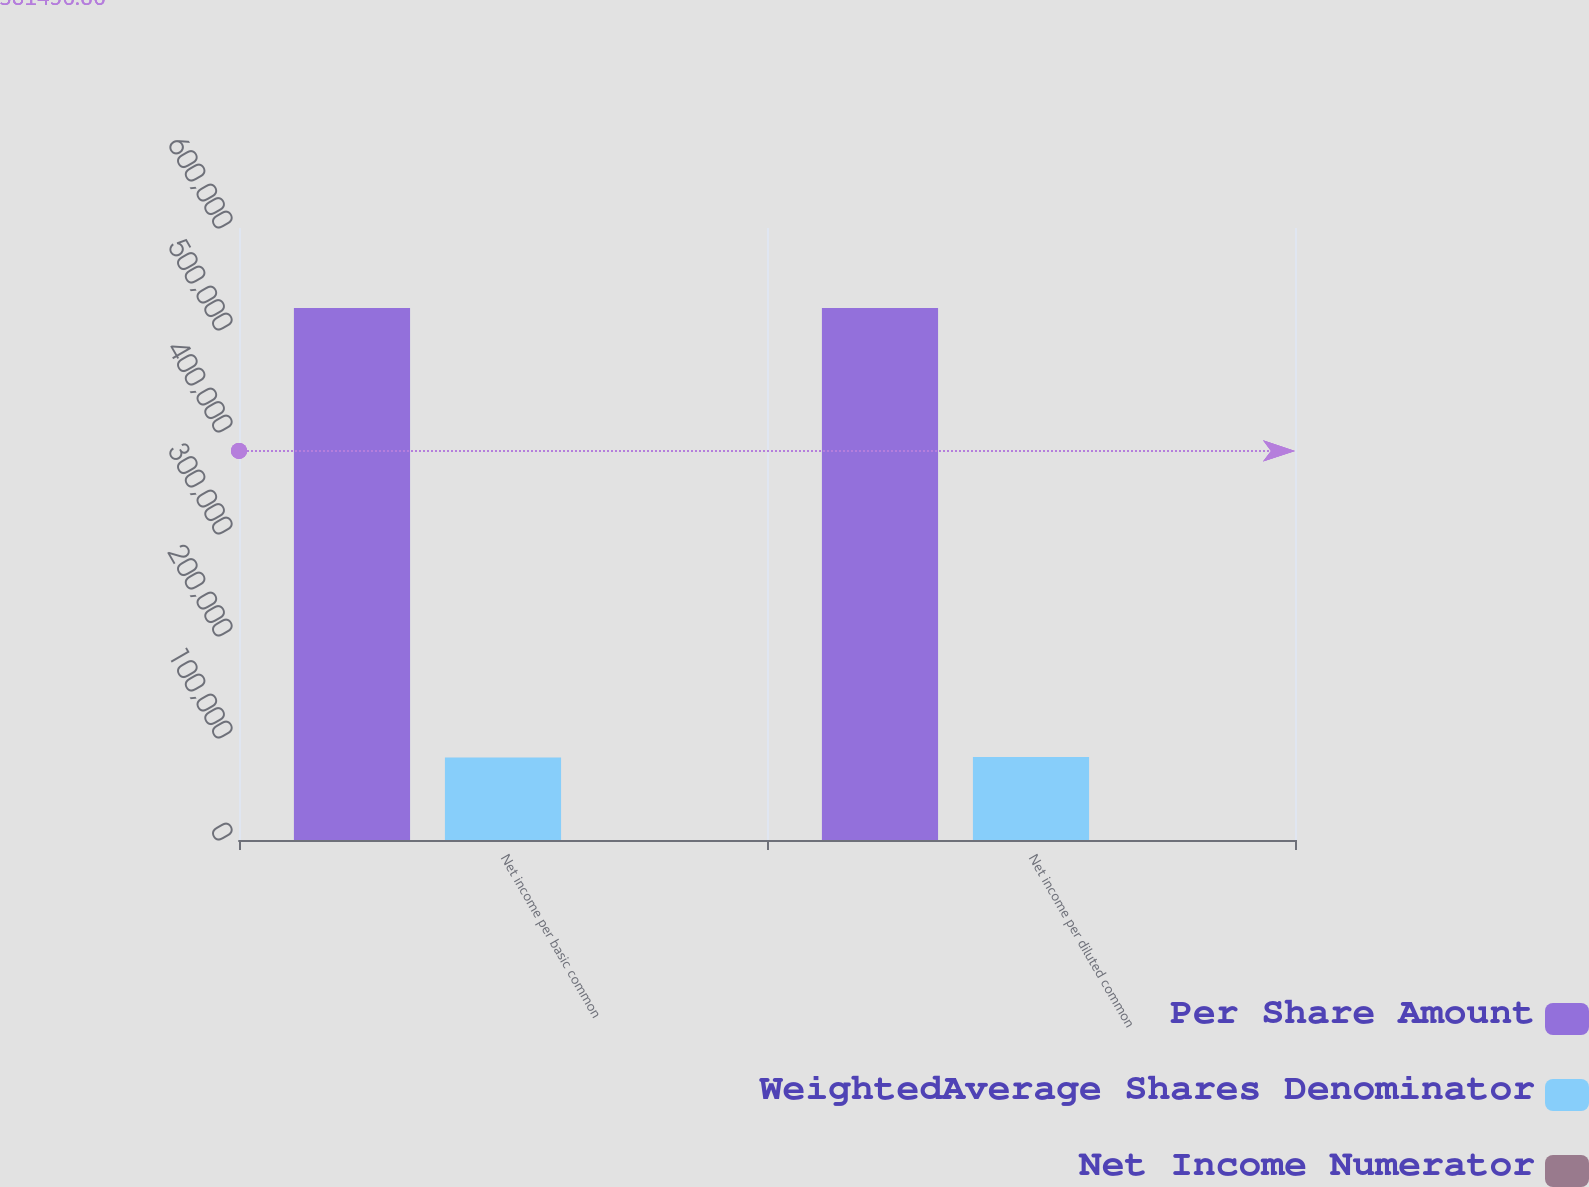<chart> <loc_0><loc_0><loc_500><loc_500><stacked_bar_chart><ecel><fcel>Net income per basic common<fcel>Net income per diluted common<nl><fcel>Per Share Amount<fcel>521503<fcel>521503<nl><fcel>WeightedAverage Shares Denominator<fcel>80786<fcel>81417<nl><fcel>Net Income Numerator<fcel>6.46<fcel>6.41<nl></chart> 